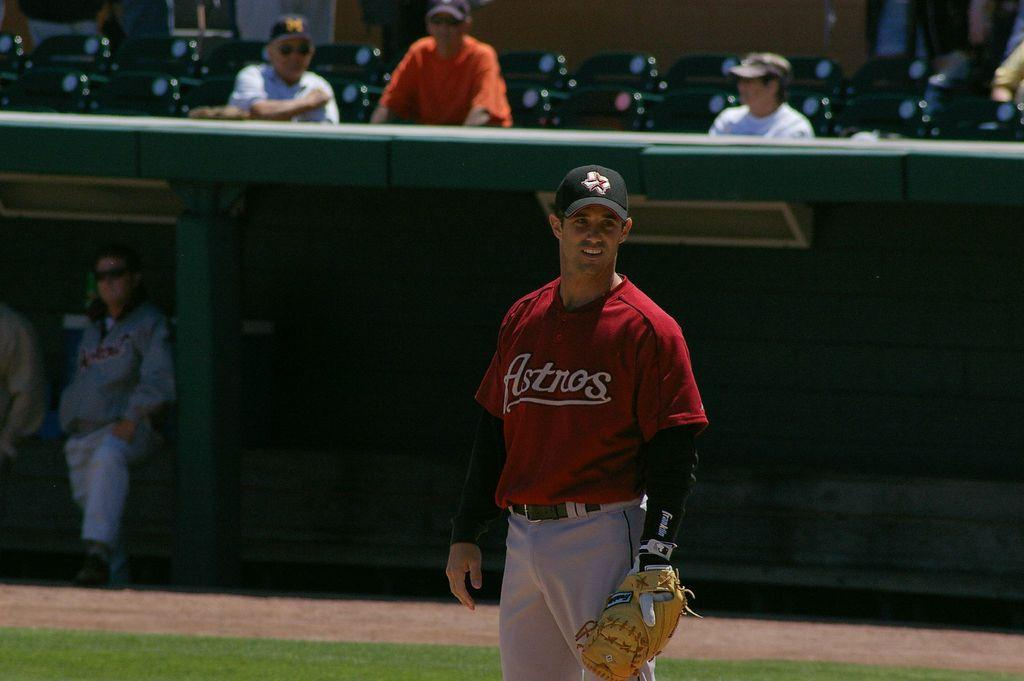<image>
Give a short and clear explanation of the subsequent image. An Astros baseball player is on the field. 